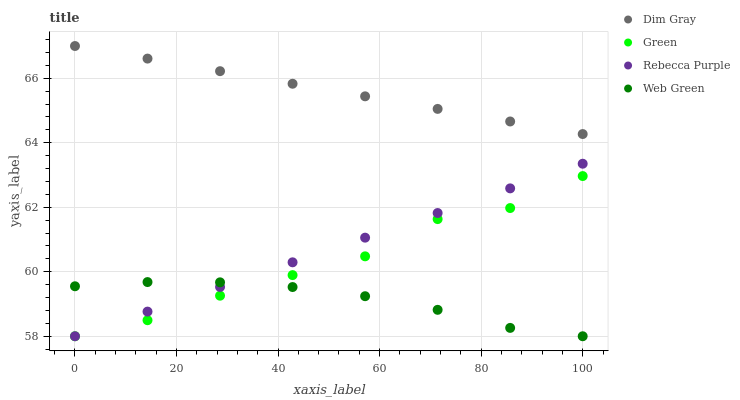Does Web Green have the minimum area under the curve?
Answer yes or no. Yes. Does Dim Gray have the maximum area under the curve?
Answer yes or no. Yes. Does Green have the minimum area under the curve?
Answer yes or no. No. Does Green have the maximum area under the curve?
Answer yes or no. No. Is Rebecca Purple the smoothest?
Answer yes or no. Yes. Is Green the roughest?
Answer yes or no. Yes. Is Green the smoothest?
Answer yes or no. No. Is Rebecca Purple the roughest?
Answer yes or no. No. Does Green have the lowest value?
Answer yes or no. Yes. Does Dim Gray have the highest value?
Answer yes or no. Yes. Does Green have the highest value?
Answer yes or no. No. Is Web Green less than Dim Gray?
Answer yes or no. Yes. Is Dim Gray greater than Web Green?
Answer yes or no. Yes. Does Rebecca Purple intersect Web Green?
Answer yes or no. Yes. Is Rebecca Purple less than Web Green?
Answer yes or no. No. Is Rebecca Purple greater than Web Green?
Answer yes or no. No. Does Web Green intersect Dim Gray?
Answer yes or no. No. 